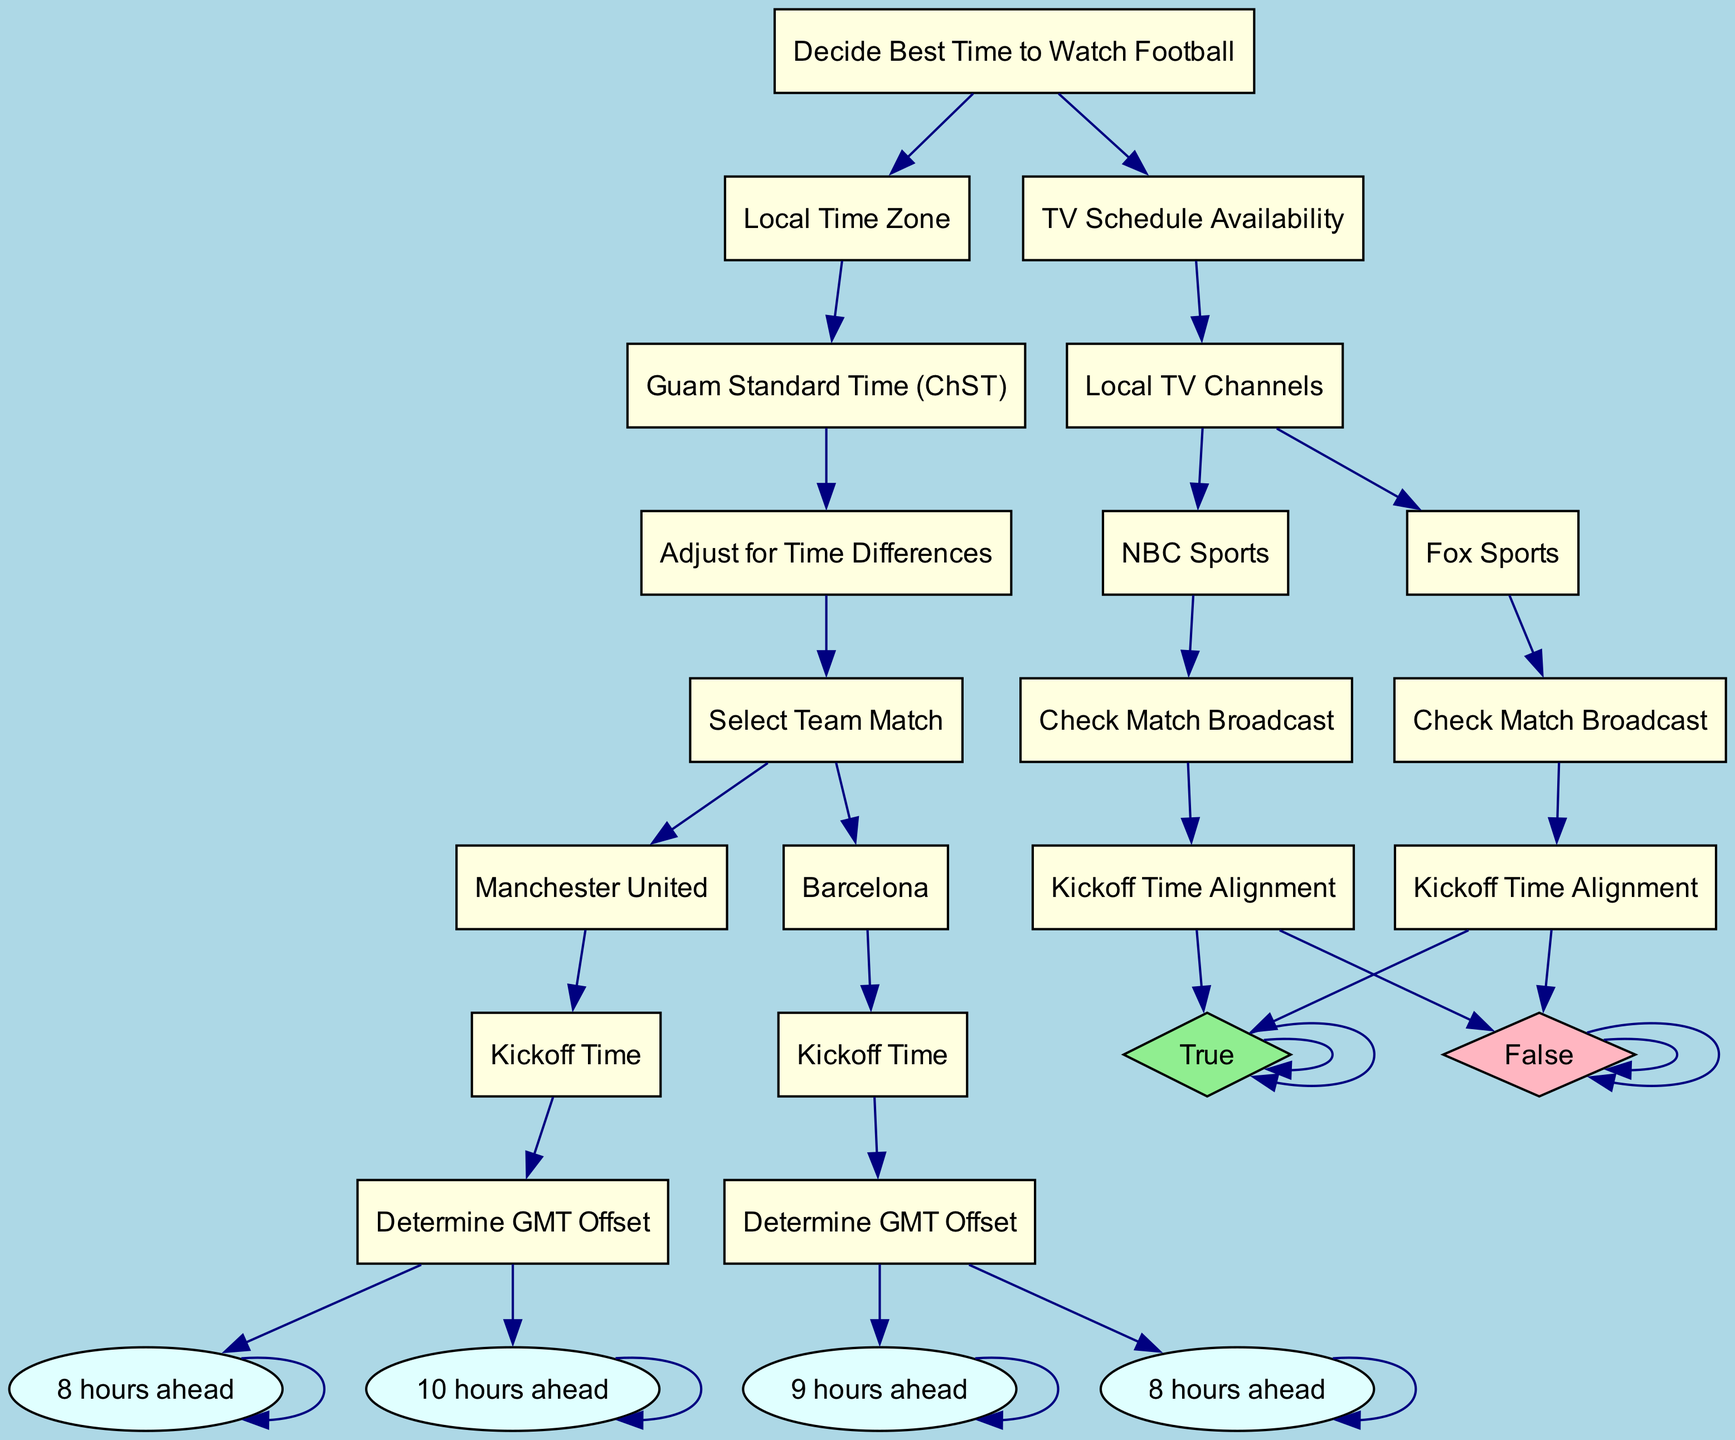What is the local time zone mentioned in the diagram? The diagram indicates that the local time zone is "Guam Standard Time (ChST)." This can be found at the beginning of the decision tree under "Local Time Zone."
Answer: Guam Standard Time (ChST) What type of match coverage is available on Fox Sports? According to the diagram's TV Schedule Availability section, Fox Sports provides "Live Coverage Available" for matches, which is stated under "Check Match Broadcast."
Answer: Live Coverage Available Which team requires determining the GMT offset that is 10 hours ahead? The diagram specifies that Manchester United requires determining the GMT offset of "10 hours ahead," which is explicitly mentioned under its section regarding kickoff time.
Answer: Manchester United How many local TV channels are listed in the diagram? The diagram lists two local TV channels: Fox Sports and NBC Sports, which are noted under the "Local TV Channels" segment of the TV Schedule Availability section.
Answer: Two What is the adjustment for Barcelona's kickoff time based on CEST? The diagram states that for Barcelona, the kickoff time adjustment is "8 hours ahead" when considering CEST, as noted under the section regarding "Determine GMT Offset."
Answer: 8 hours ahead Is there delayed coverage available on NBC Sports? Yes, the diagram clearly indicates that "Delayed Coverage Available" is true for NBC Sports, aligning with the information under "Check Match Broadcast."
Answer: True What is the GMT offset for British Summer Time? The diagram specifies that the GMT offset for British Summer Time (BST) is "8 hours ahead," which is directly stated under the "Determine GMT Offset" for Manchester United.
Answer: 8 hours ahead What decision does one make if live coverage is not available? According to the diagram, if "Live Coverage Available" is false, one would need to rely on delayed coverage, as indicated under "Check Match Broadcast."
Answer: Delayed Coverage 